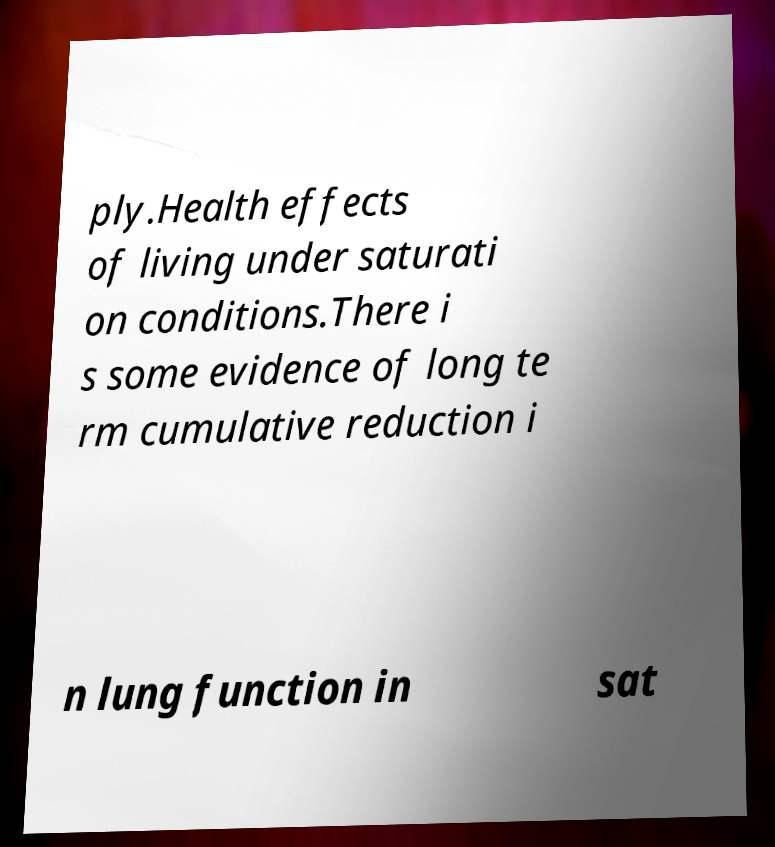Could you extract and type out the text from this image? ply.Health effects of living under saturati on conditions.There i s some evidence of long te rm cumulative reduction i n lung function in sat 